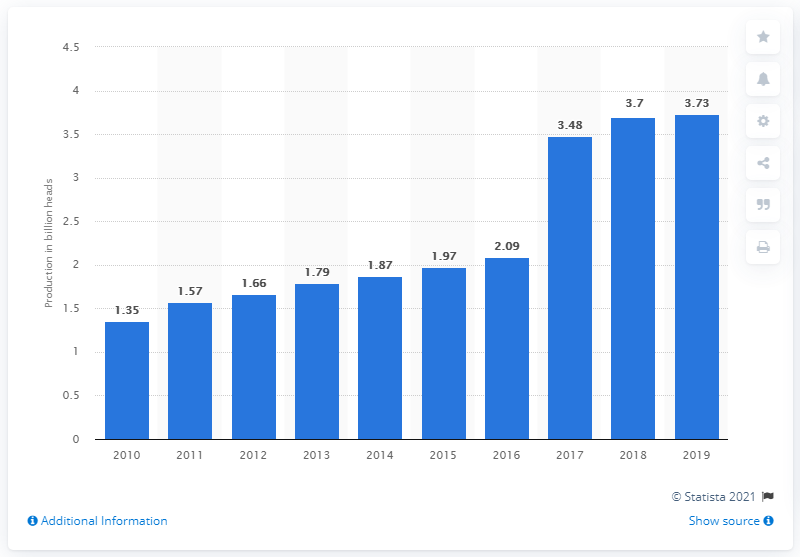Mention a couple of crucial points in this snapshot. In 2019, a total of 3.73 million chickens were produced in Indonesia. 